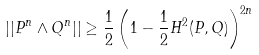Convert formula to latex. <formula><loc_0><loc_0><loc_500><loc_500>| | { P } ^ { n } \wedge { Q } ^ { n } | | \geq \frac { 1 } { 2 } \left ( 1 - \frac { 1 } { 2 } { H } ^ { 2 } ( { P } , { Q } ) \right ) ^ { 2 n }</formula> 